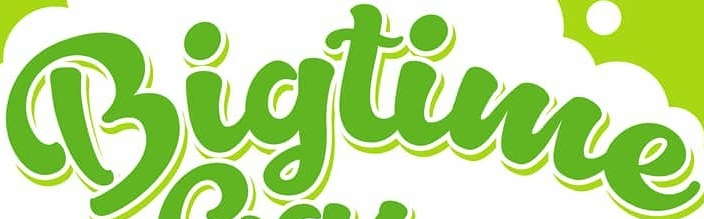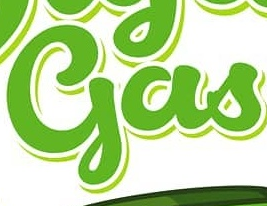Read the text from these images in sequence, separated by a semicolon. Bigtime; gas 